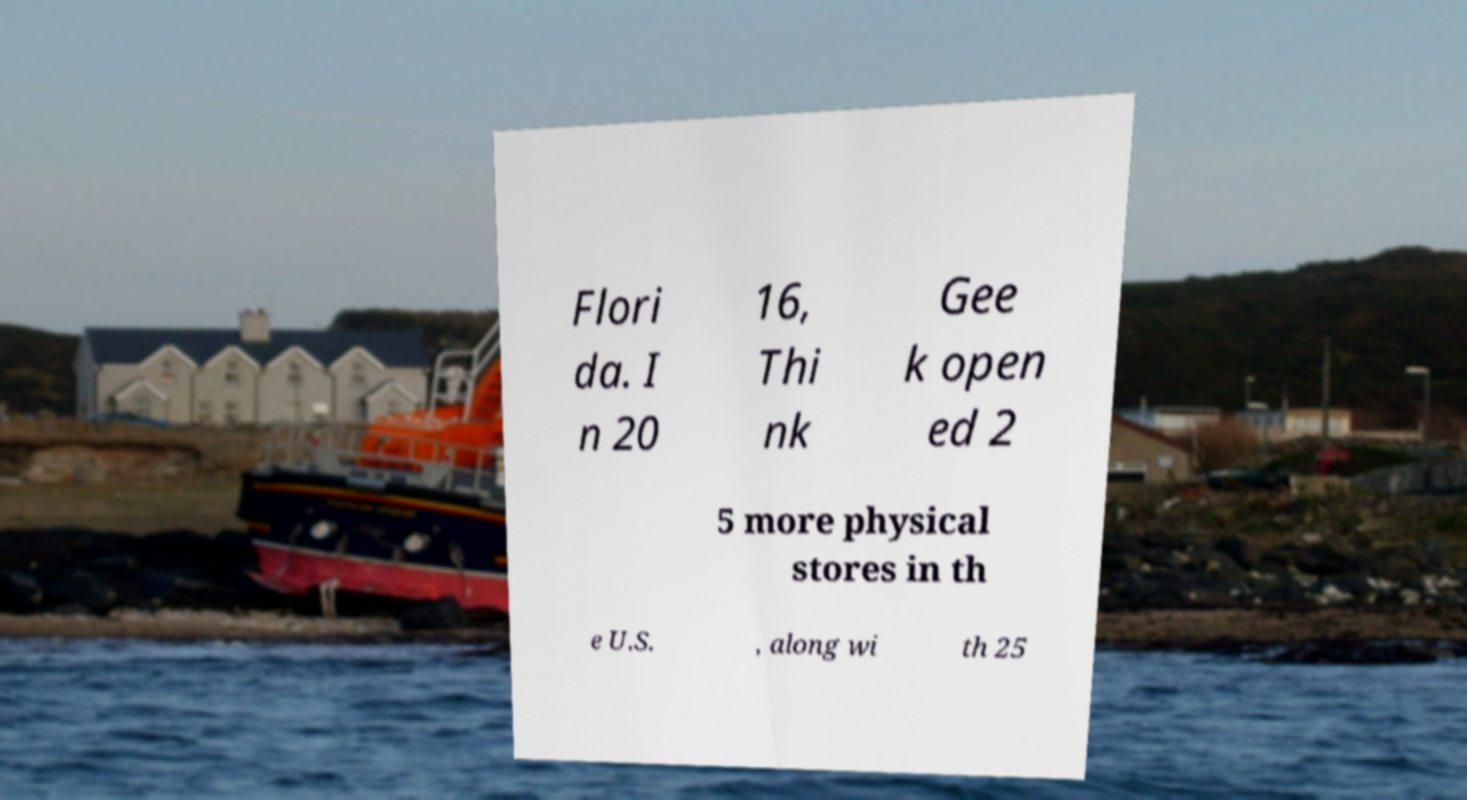I need the written content from this picture converted into text. Can you do that? Flori da. I n 20 16, Thi nk Gee k open ed 2 5 more physical stores in th e U.S. , along wi th 25 